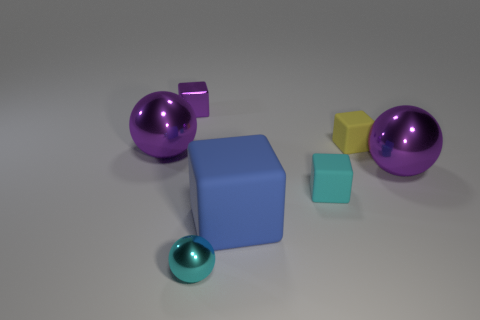Subtract all cyan cubes. How many cubes are left? 3 Add 1 green metallic spheres. How many objects exist? 8 Subtract all yellow cylinders. How many purple spheres are left? 2 Subtract all blue cubes. How many cubes are left? 3 Subtract 2 balls. How many balls are left? 1 Subtract all blocks. How many objects are left? 3 Subtract all cyan things. Subtract all purple blocks. How many objects are left? 4 Add 1 large rubber cubes. How many large rubber cubes are left? 2 Add 4 large green metallic spheres. How many large green metallic spheres exist? 4 Subtract 0 red cubes. How many objects are left? 7 